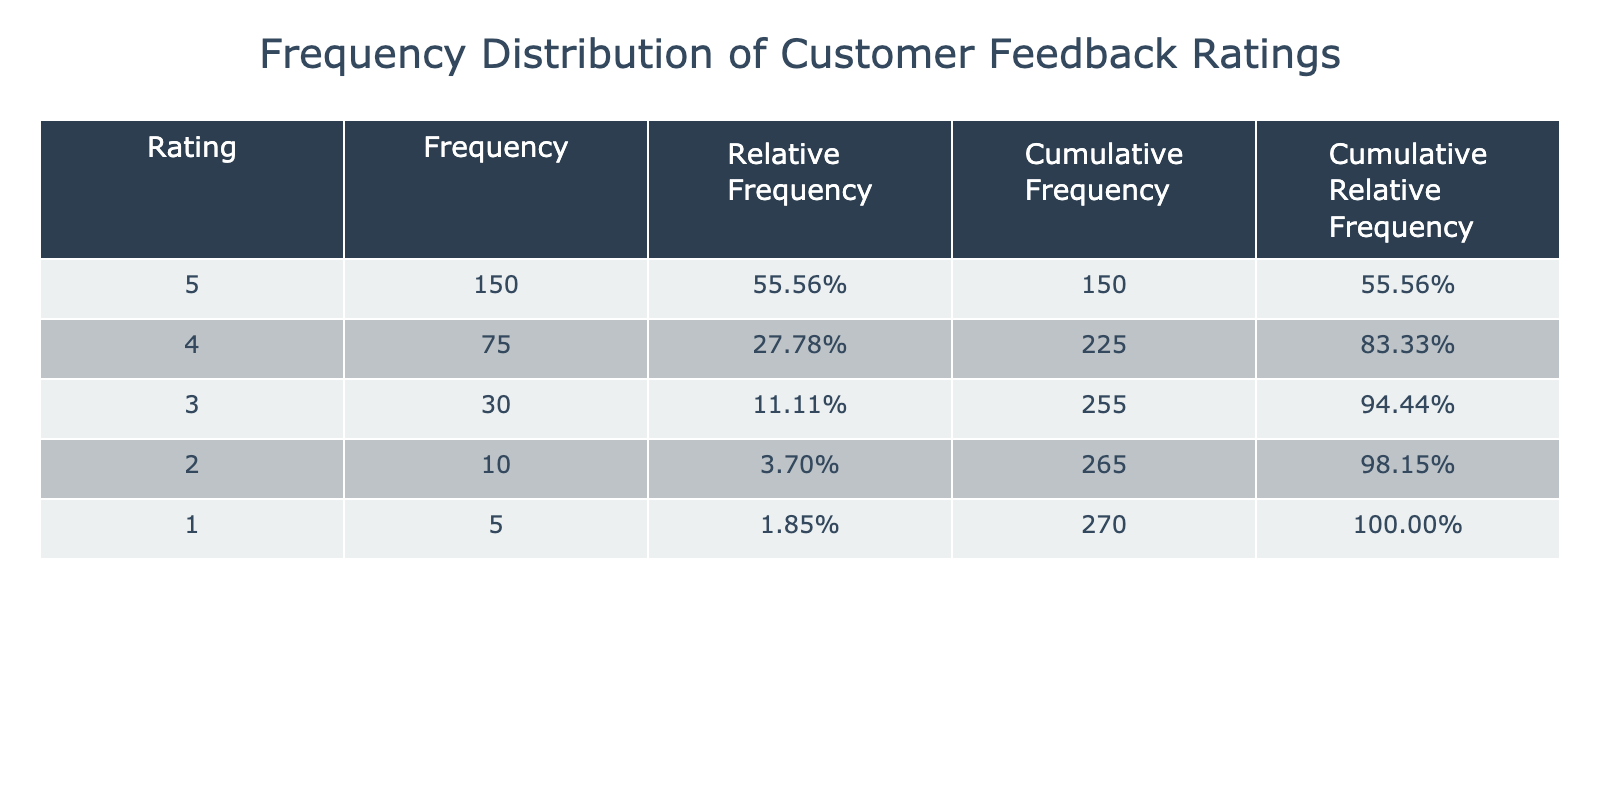What is the highest frequency rating given by customers? The highest frequency corresponds to the rating in the first row. Looking at the table, the rating of 5 has a frequency of 150.
Answer: 5 What is the cumulative frequency for a rating of 3? To find the cumulative frequency for a rating of 3, sum up the frequencies of the ratings 5, 4, and 3. This is calculated as 150 (for 5) + 75 (for 4) + 30 (for 3) = 255.
Answer: 255 What proportion of customers rated the product 4 or higher? First, we find the total frequency for ratings 4 and 5: 75 (for 4) + 150 (for 5) = 225. The total frequency of all ratings is 150 + 75 + 30 + 10 + 5 = 270. The proportion is calculated as 225 / 270, which is approximately 0.833 or 83.33%.
Answer: 83.33% Is the frequency of rating 1 greater than the frequency of rating 2? The frequency for rating 1 is 5, and for rating 2 it is 10. Since 5 is not greater than 10, the statement is false.
Answer: No What is the average rating given by customers based on the frequency? To calculate the average rating, multiply each rating by its frequency: (5*150 + 4*75 + 3*30 + 2*10 + 1*5) / total frequency. This is (750 + 300 + 90 + 20 + 5) / 270 = 1145 / 270 ≈ 4.24.
Answer: 4.24 What is the cumulative relative frequency for all ratings combined? The cumulative relative frequency for all ratings combined must equal 100%, as it accounts for all ratings. This means the cumulative relative frequency of the last rating (1) will be equal to 1.
Answer: 100% How many customers rated the product below a 3? To find the number of ratings below a 3, sum the frequencies for ratings 1 and 2: 5 (for 1) + 10 (for 2) = 15.
Answer: 15 What is the difference in frequency between the highest and the lowest rating? The highest frequency is for rating 5, which is 150, and the lowest frequency is for rating 1, which is 5. The difference is 150 - 5 = 145.
Answer: 145 What percentage of ratings received a score of 2 or less? To find this percentage, sum the frequencies for ratings 1 and 2: 5 (for 1) + 10 (for 2) = 15. The total frequency is 270, so the percentage is calculated as (15 / 270) * 100 ≈ 5.56%.
Answer: 5.56% 